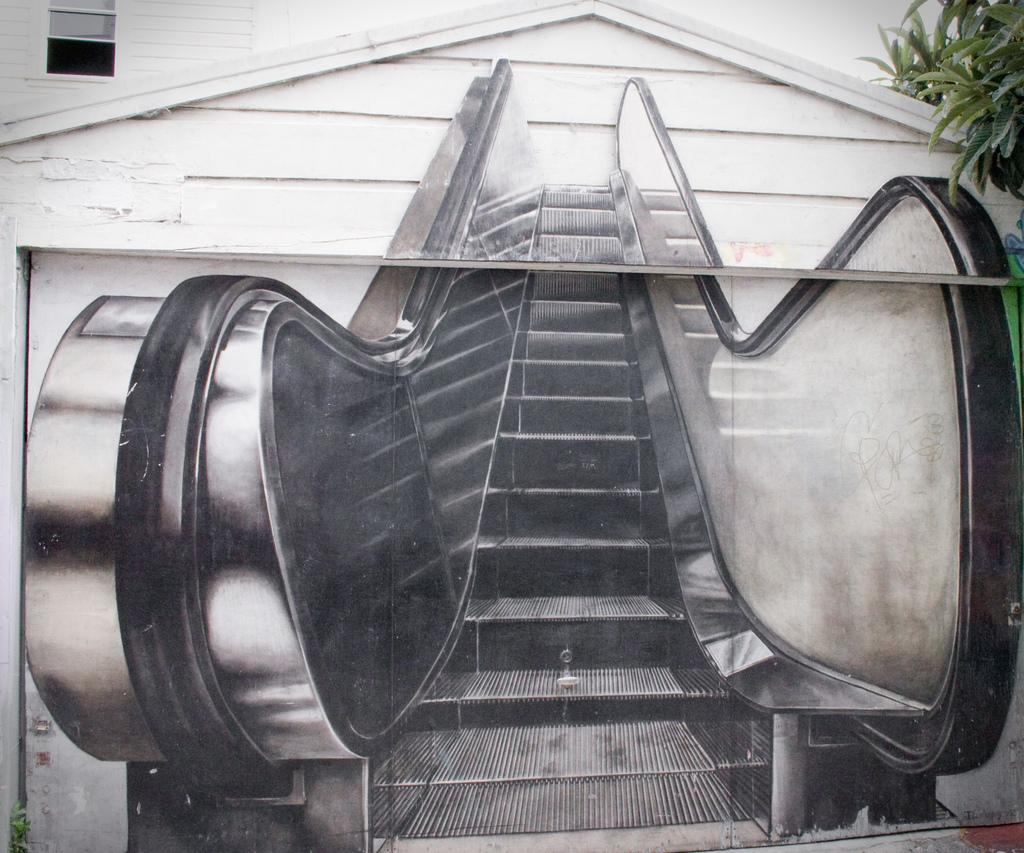What is depicted on the wall in the image? There is an escalator painting on a wall in the image. What architectural feature can be seen in the image? There is a window in the image. What can be seen through the window? Green leaves are visible through the window. How many cows are grazing on the slope outside the window? There are no cows or slope visible in the image; only green leaves can be seen through the window. 